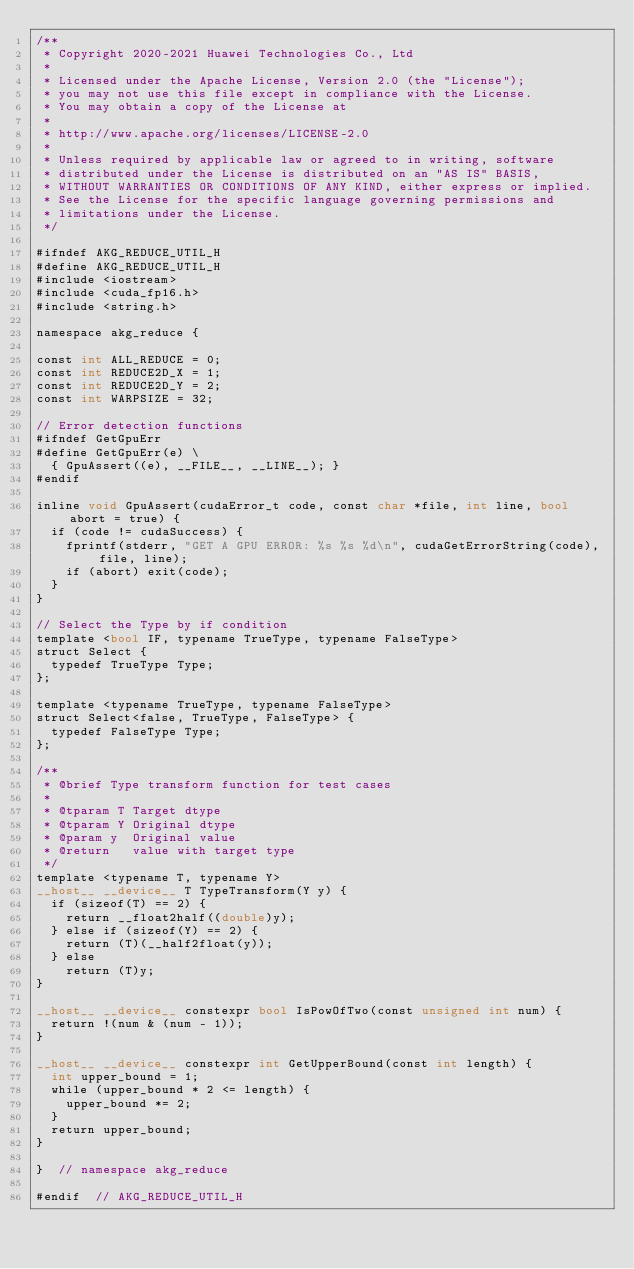Convert code to text. <code><loc_0><loc_0><loc_500><loc_500><_Cuda_>/**
 * Copyright 2020-2021 Huawei Technologies Co., Ltd
 *
 * Licensed under the Apache License, Version 2.0 (the "License");
 * you may not use this file except in compliance with the License.
 * You may obtain a copy of the License at
 *
 * http://www.apache.org/licenses/LICENSE-2.0
 *
 * Unless required by applicable law or agreed to in writing, software
 * distributed under the License is distributed on an "AS IS" BASIS,
 * WITHOUT WARRANTIES OR CONDITIONS OF ANY KIND, either express or implied.
 * See the License for the specific language governing permissions and
 * limitations under the License.
 */

#ifndef AKG_REDUCE_UTIL_H
#define AKG_REDUCE_UTIL_H
#include <iostream>
#include <cuda_fp16.h>
#include <string.h>

namespace akg_reduce {

const int ALL_REDUCE = 0;
const int REDUCE2D_X = 1;
const int REDUCE2D_Y = 2;
const int WARPSIZE = 32;

// Error detection functions
#ifndef GetGpuErr
#define GetGpuErr(e) \
  { GpuAssert((e), __FILE__, __LINE__); }
#endif

inline void GpuAssert(cudaError_t code, const char *file, int line, bool abort = true) {
  if (code != cudaSuccess) {
    fprintf(stderr, "GET A GPU ERROR: %s %s %d\n", cudaGetErrorString(code), file, line);
    if (abort) exit(code);
  }
}

// Select the Type by if condition
template <bool IF, typename TrueType, typename FalseType>
struct Select {
  typedef TrueType Type;
};

template <typename TrueType, typename FalseType>
struct Select<false, TrueType, FalseType> {
  typedef FalseType Type;
};

/**
 * @brief Type transform function for test cases
 *
 * @tparam T Target dtype
 * @tparam Y Original dtype
 * @param y  Original value
 * @return   value with target type
 */
template <typename T, typename Y>
__host__ __device__ T TypeTransform(Y y) {
  if (sizeof(T) == 2) {
    return __float2half((double)y);
  } else if (sizeof(Y) == 2) {
    return (T)(__half2float(y));
  } else
    return (T)y;
}

__host__ __device__ constexpr bool IsPowOfTwo(const unsigned int num) { 
  return !(num & (num - 1)); 
}

__host__ __device__ constexpr int GetUpperBound(const int length) {
  int upper_bound = 1;
  while (upper_bound * 2 <= length) {
    upper_bound *= 2;
  }
  return upper_bound;
}

}  // namespace akg_reduce

#endif  // AKG_REDUCE_UTIL_H</code> 